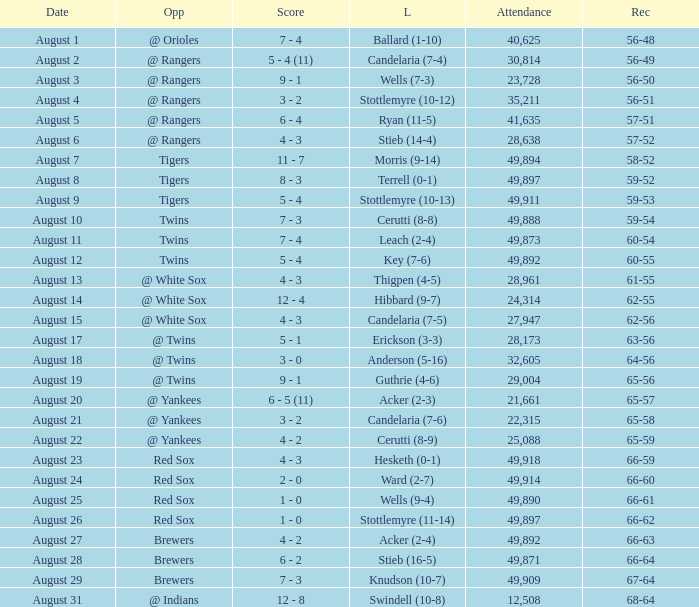What was the record of the game that had a loss of Stottlemyre (10-12)? 56-51. 